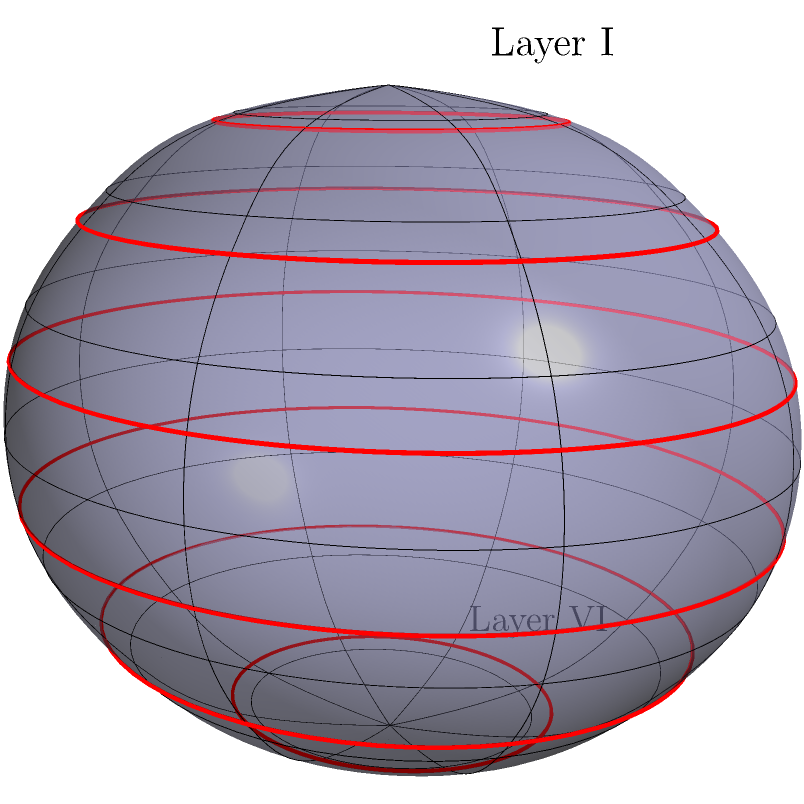In the context of mapping cortical layers onto a 3D surface representation of the brain, consider the spherical model shown above. The red circles represent different cortical layers. How would the surface area of these layers change from the outermost (Layer I) to the innermost (Layer VI) layer, and what implication does this have for the organization of neurons in these layers? To answer this question, we need to consider the geometry of a sphere and how it relates to cortical layer organization:

1. In a sphere, the surface area is given by the formula $A = 4\pi r^2$, where $r$ is the radius.

2. As we move from the outermost layer (Layer I) to the innermost layer (Layer VI), the radius decreases.

3. Due to the quadratic relationship between radius and surface area, a small decrease in radius results in a larger decrease in surface area.

4. Mathematically, if we consider two layers with radii $r_1$ and $r_2$, where $r_1 > r_2$, the ratio of their surface areas would be:

   $\frac{A_1}{A_2} = \frac{4\pi r_1^2}{4\pi r_2^2} = (\frac{r_1}{r_2})^2$

5. This means that the surface area decreases more rapidly than the radius as we move inward.

6. In the context of cortical layers, this implies that the deeper layers have significantly less surface area than the outer layers.

7. The biological implication is that there is less physical space available for neurons in the deeper layers compared to the outer layers.

8. To maintain computational capacity, the brain may compensate for this by:
   a) Increasing the density of neurons in deeper layers
   b) Changing the types or functions of neurons in different layers
   c) Altering the connectivity patterns between layers

9. This geometric constraint is one factor that contributes to the distinct cytoarchitecture and function of different cortical layers.
Answer: Surface area decreases non-linearly from outer to inner layers, leading to differential neuron organization and connectivity across layers. 